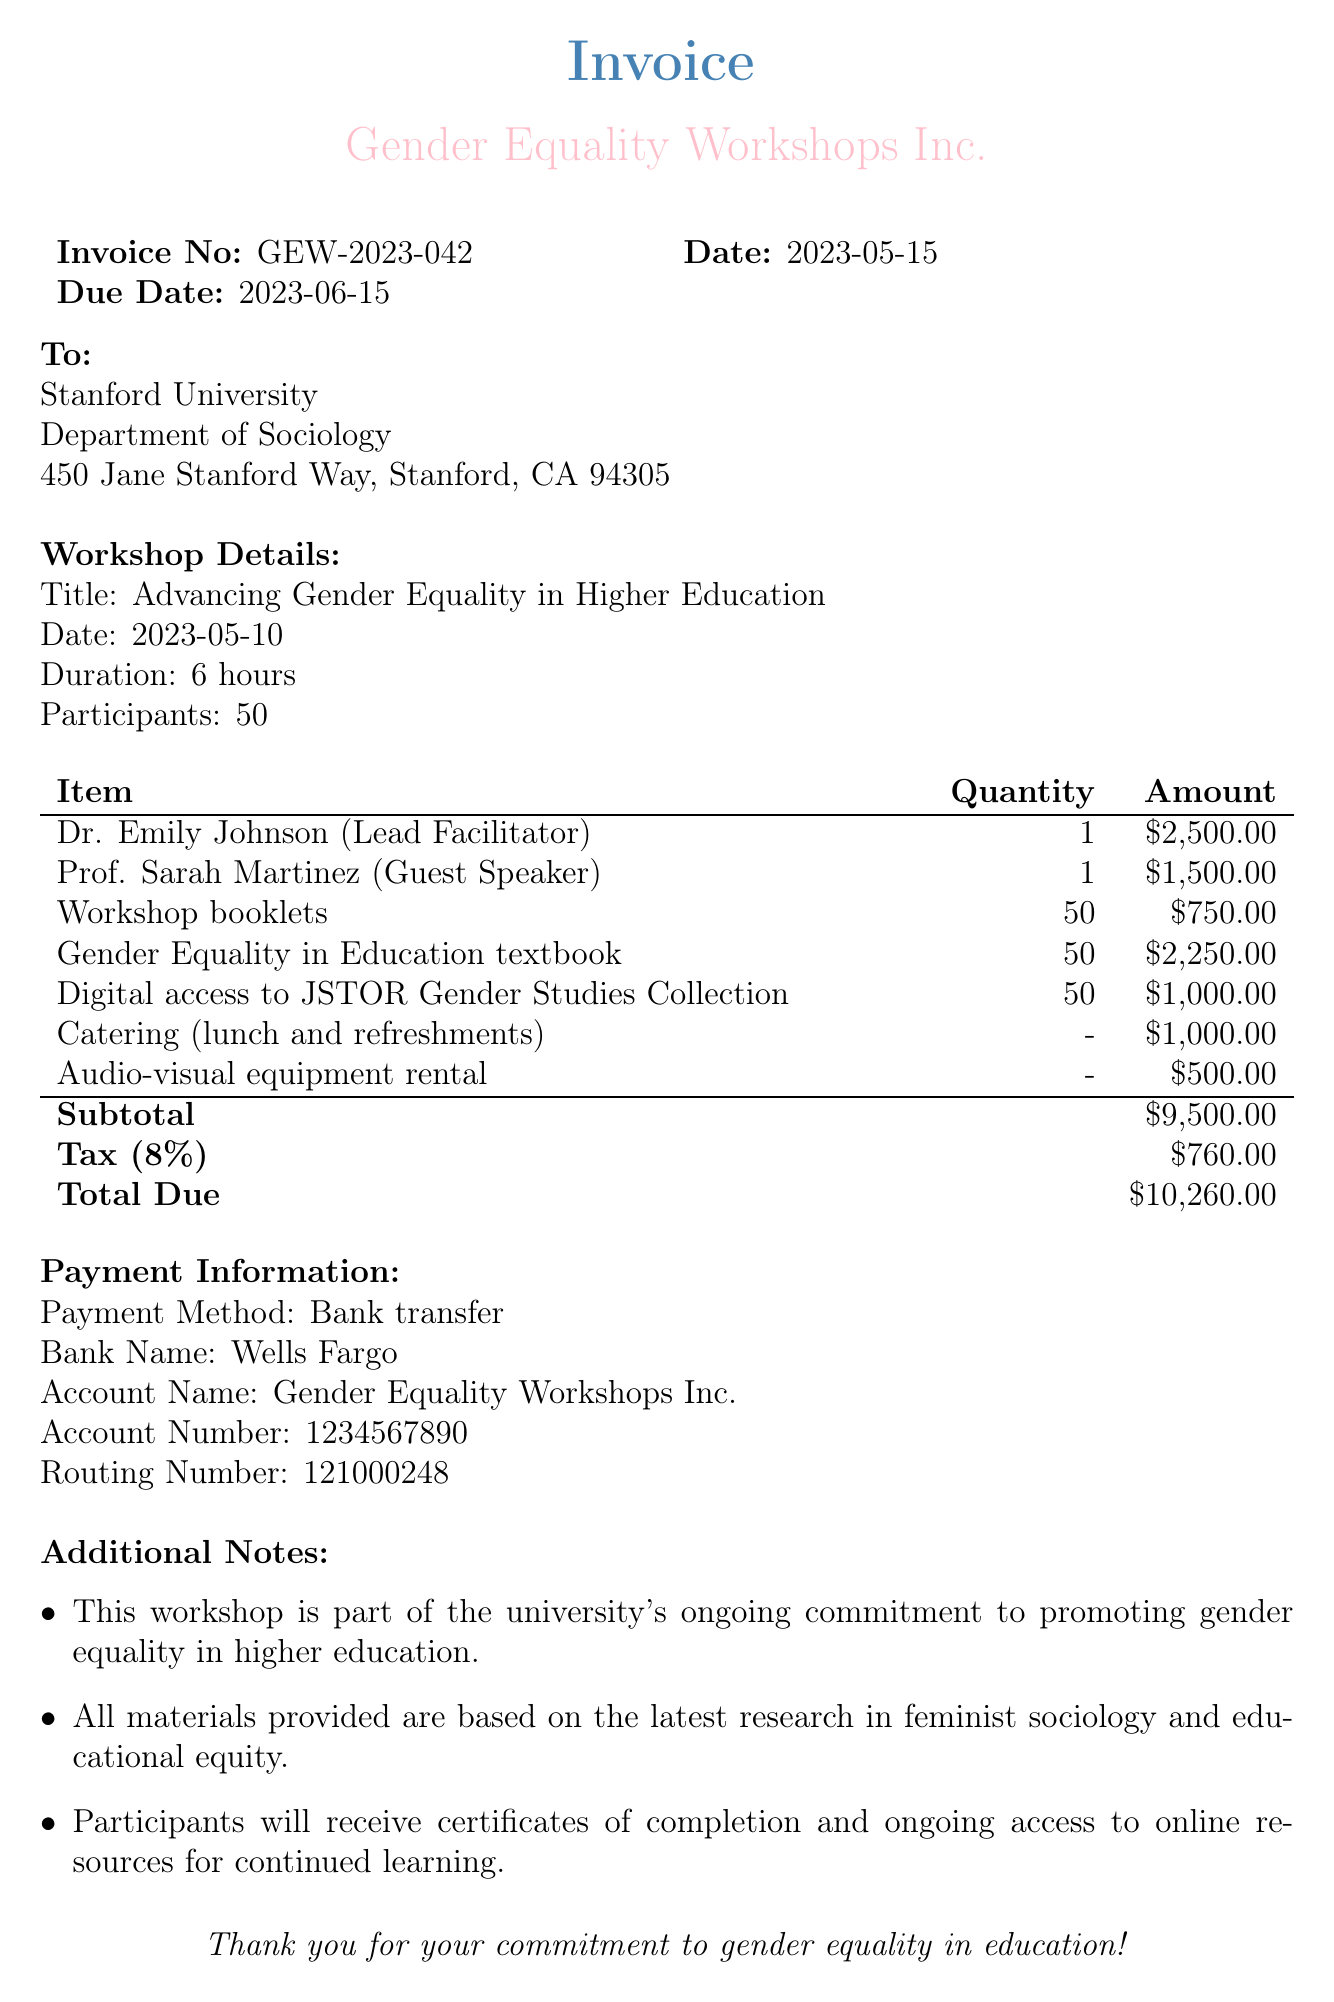What is the invoice number? The invoice number is listed in the document under invoice details.
Answer: GEW-2023-042 Who is the lead facilitator? The lead facilitator's name is found in the speaker fees section of the document.
Answer: Dr. Emily Johnson What is the total due amount? The total due amount is summarized at the end of the document.
Answer: $10,260.00 How many participants attended the workshop? The number of participants is stated in the workshop details section of the document.
Answer: 50 What is the quantity of Gender Equality in Education textbooks? The quantity for the textbooks is mentioned in the materials costs section of the document.
Answer: 50 What is the tax rate applied to the invoice? The tax rate is indicated in the summary section of the document.
Answer: 8% What is the payment method? The payment method is specified in the payment information section of the document.
Answer: Bank transfer What additional note emphasizes ongoing access to resources? This information is highlighted in the additional notes section of the document.
Answer: Participants will receive certificates of completion and ongoing access to online resources for continued learning What is the address of Stanford University? The address is listed in the "To" section of the document.
Answer: 450 Jane Stanford Way, Stanford, CA 94305 